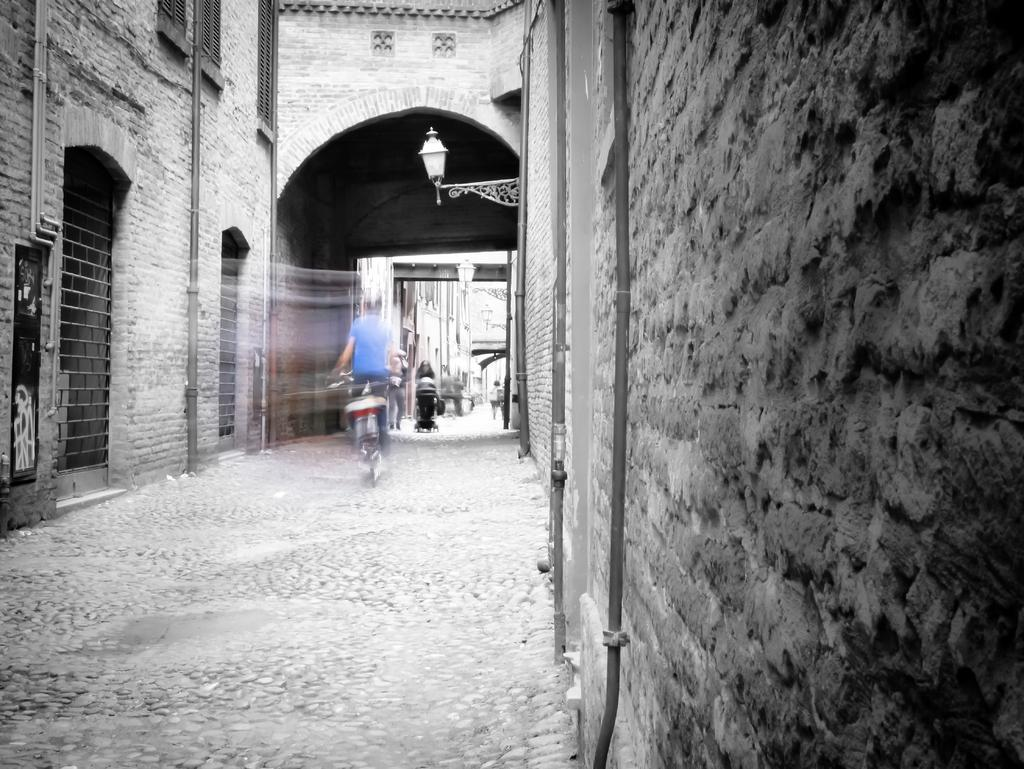What type of structures can be seen in the image? There are buildings in the image. Are there any people visible in the image? Yes, there are persons in the image. What architectural feature is present in the image? There is an arch in the image. What else can be seen in the image besides buildings and persons? There are poles in the image. What type of vegetable is being sold by the beggar in the image? There is no beggar or vegetable present in the image. What kind of pancake is being flipped by the person in the image? There is no pancake or person flipping a pancake present in the image. 